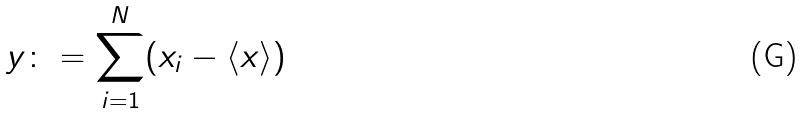<formula> <loc_0><loc_0><loc_500><loc_500>y \colon = \sum _ { i = 1 } ^ { N } ( x _ { i } - \langle x \rangle )</formula> 